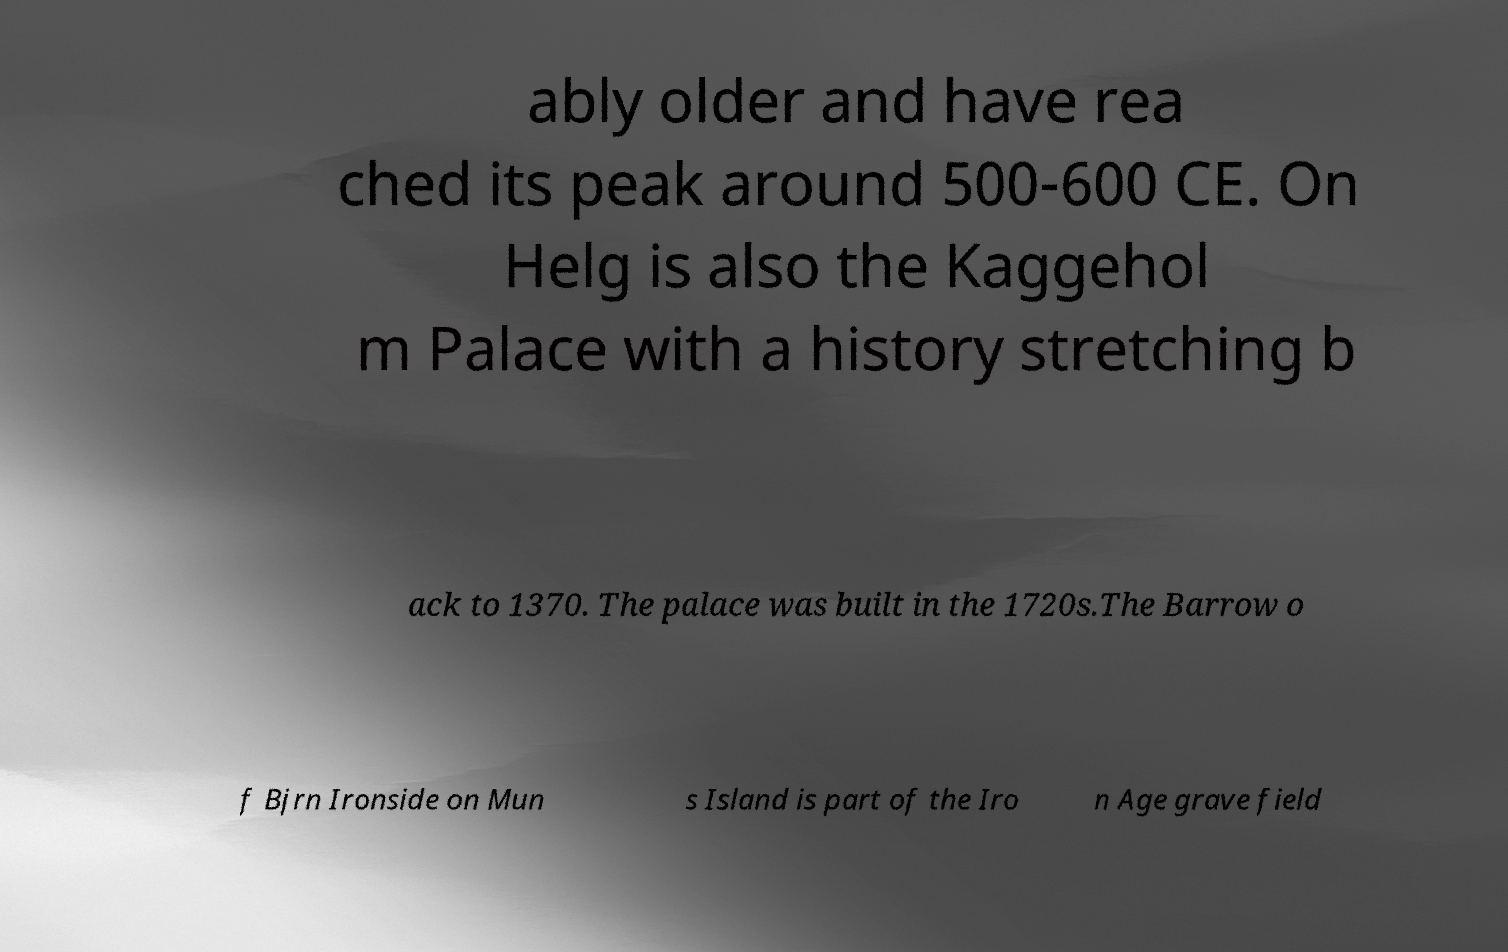I need the written content from this picture converted into text. Can you do that? ably older and have rea ched its peak around 500-600 CE. On Helg is also the Kaggehol m Palace with a history stretching b ack to 1370. The palace was built in the 1720s.The Barrow o f Bjrn Ironside on Mun s Island is part of the Iro n Age grave field 